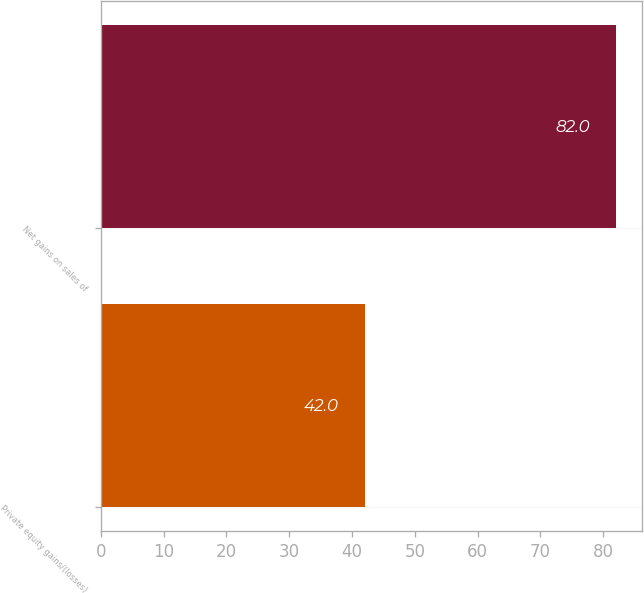Convert chart to OTSL. <chart><loc_0><loc_0><loc_500><loc_500><bar_chart><fcel>Private equity gains/(losses)<fcel>Net gains on sales of<nl><fcel>42<fcel>82<nl></chart> 